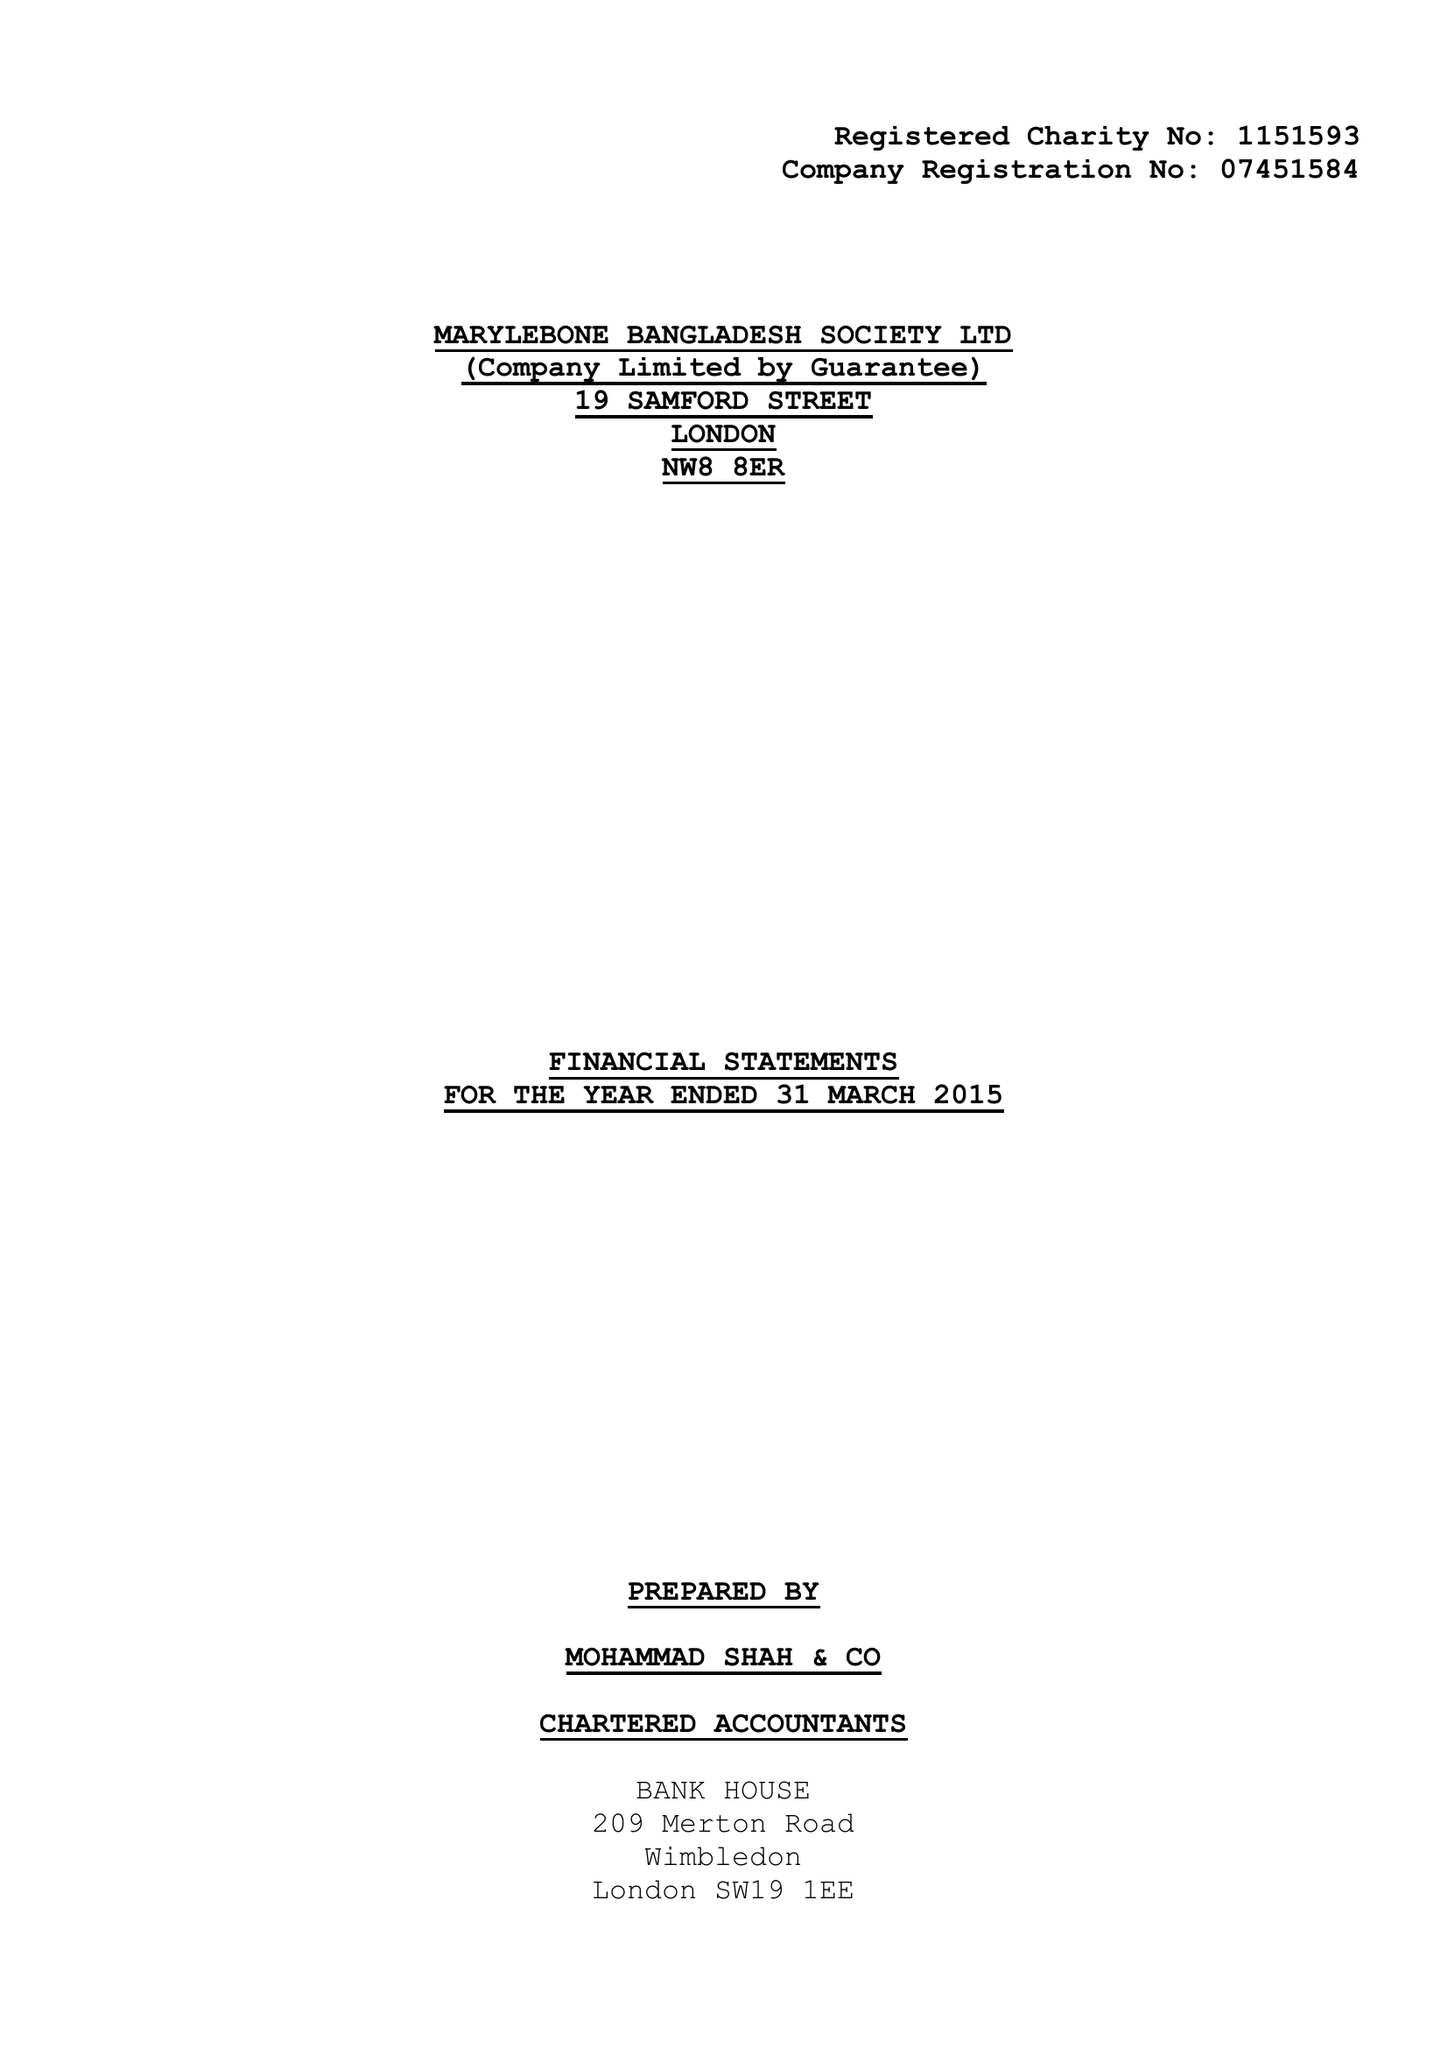What is the value for the address__street_line?
Answer the question using a single word or phrase. 19 SAMFORD STREET 